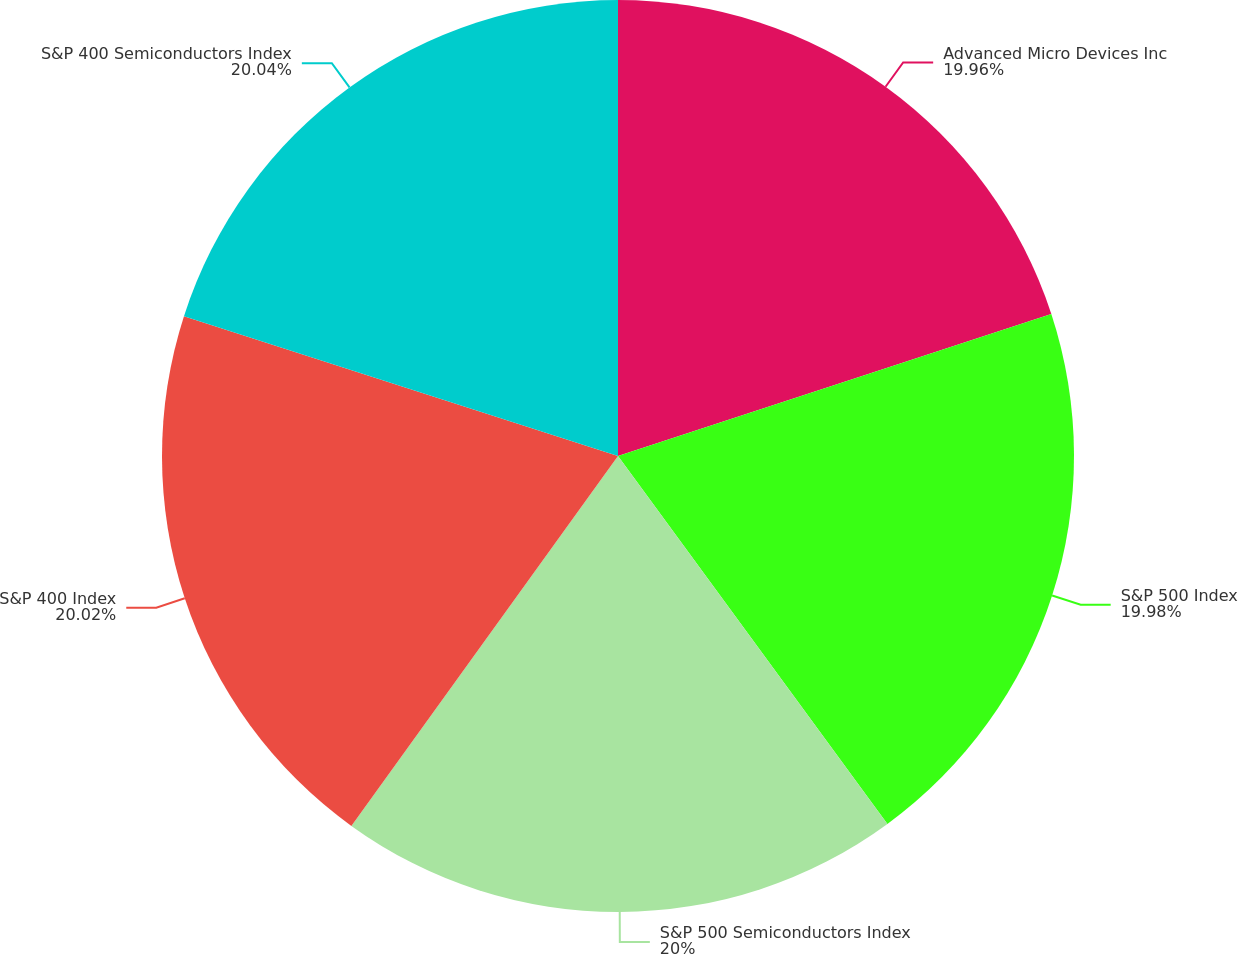<chart> <loc_0><loc_0><loc_500><loc_500><pie_chart><fcel>Advanced Micro Devices Inc<fcel>S&P 500 Index<fcel>S&P 500 Semiconductors Index<fcel>S&P 400 Index<fcel>S&P 400 Semiconductors Index<nl><fcel>19.96%<fcel>19.98%<fcel>20.0%<fcel>20.02%<fcel>20.04%<nl></chart> 